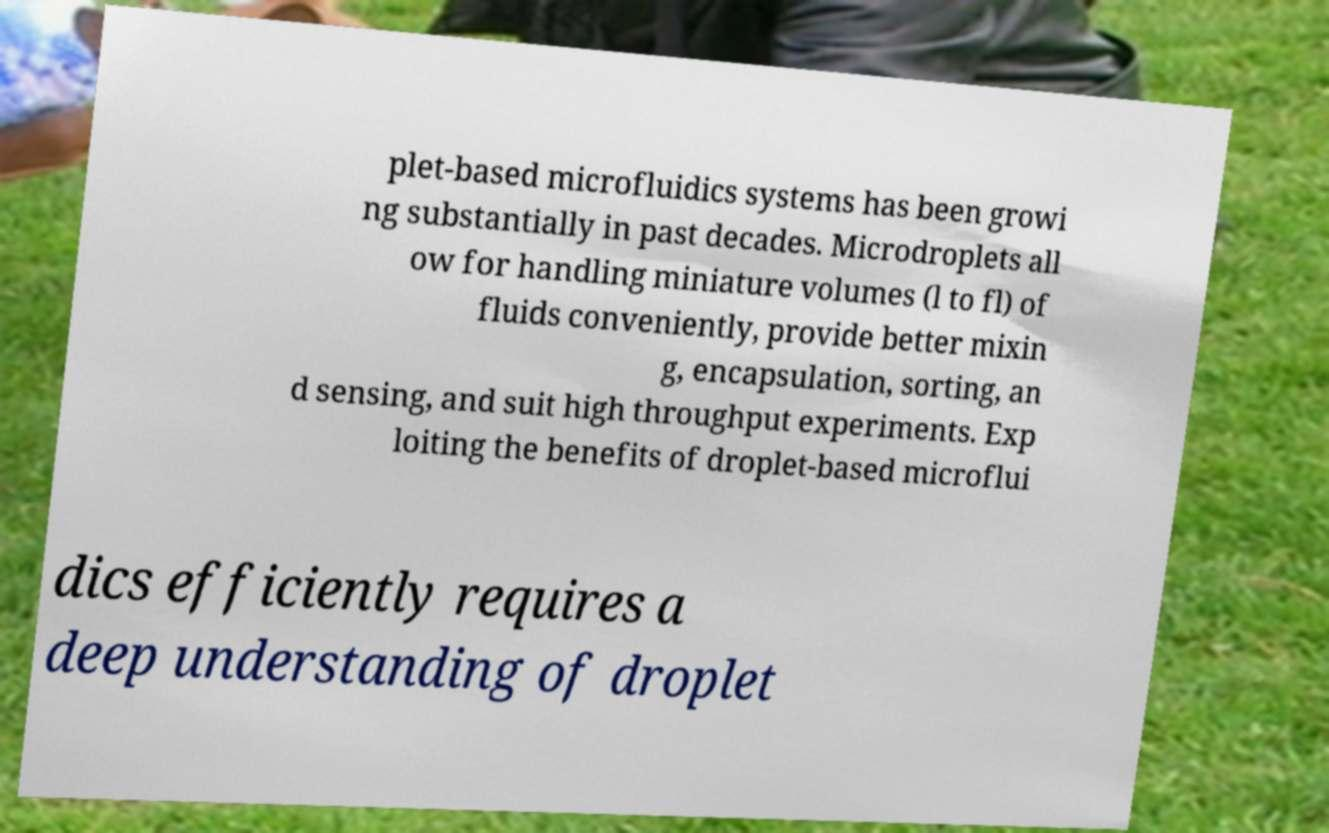Could you assist in decoding the text presented in this image and type it out clearly? plet-based microfluidics systems has been growi ng substantially in past decades. Microdroplets all ow for handling miniature volumes (l to fl) of fluids conveniently, provide better mixin g, encapsulation, sorting, an d sensing, and suit high throughput experiments. Exp loiting the benefits of droplet-based microflui dics efficiently requires a deep understanding of droplet 